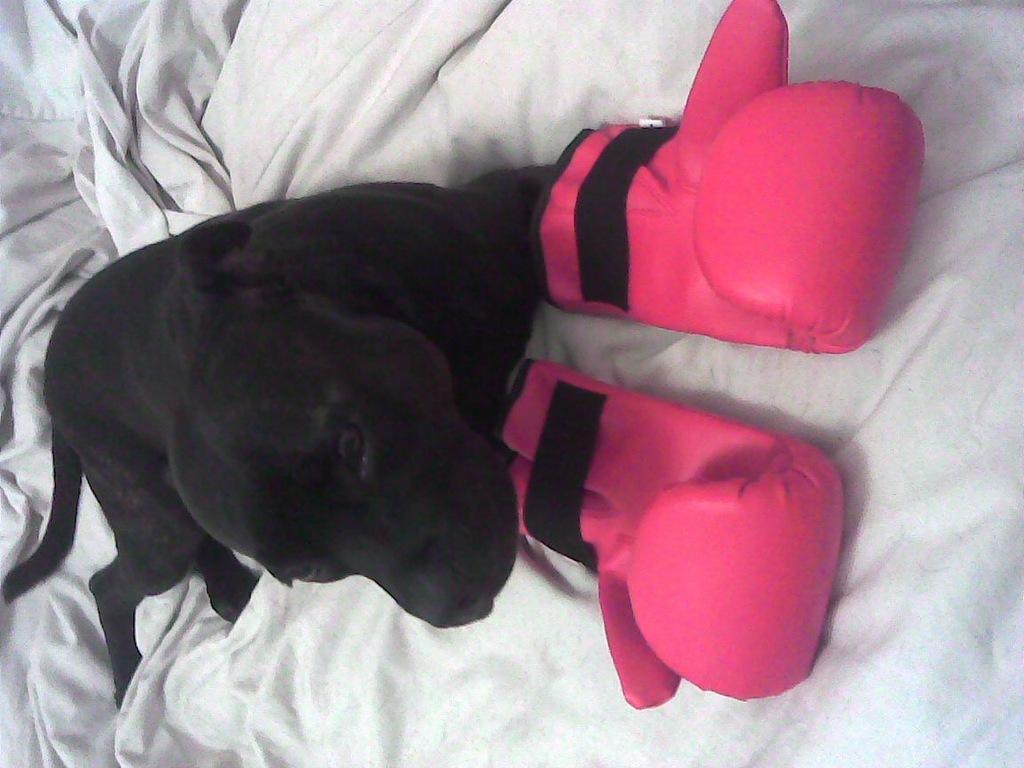How would you summarize this image in a sentence or two? The picture consists of a bed covered with blanket, on the bed there is a black colored dog wearing gloves. 